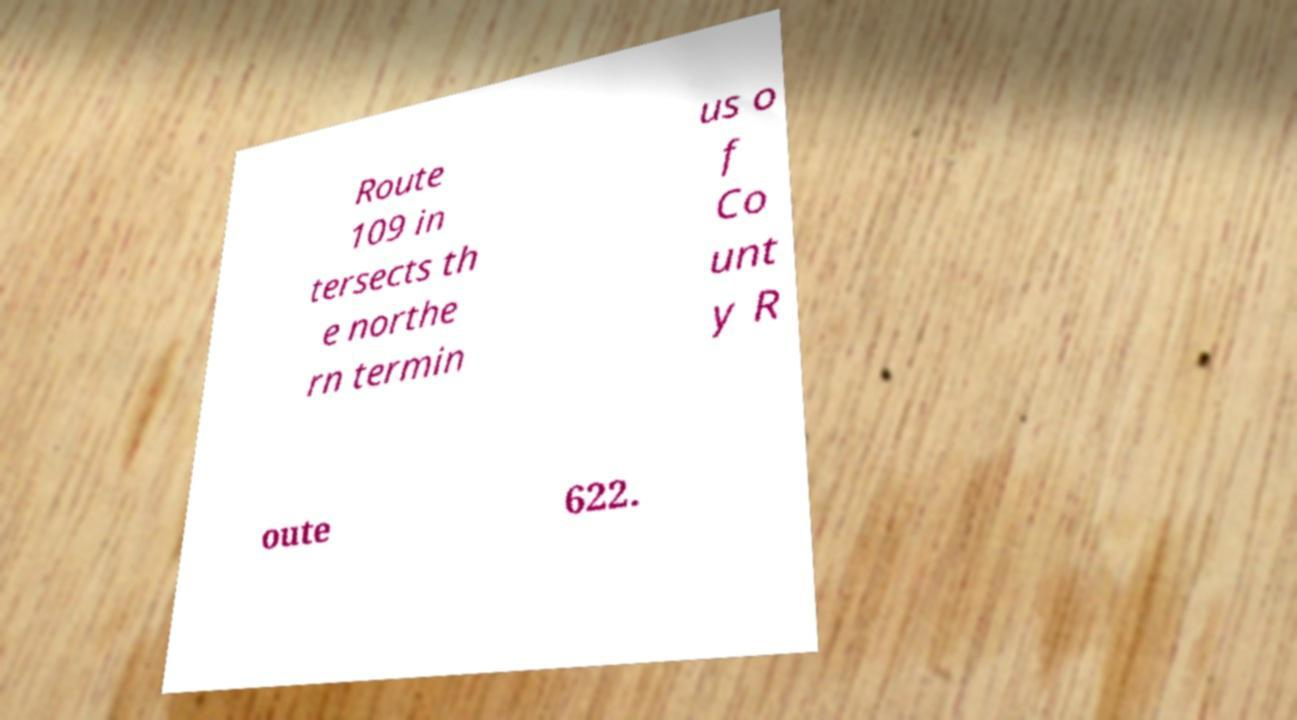Please read and relay the text visible in this image. What does it say? Route 109 in tersects th e northe rn termin us o f Co unt y R oute 622. 